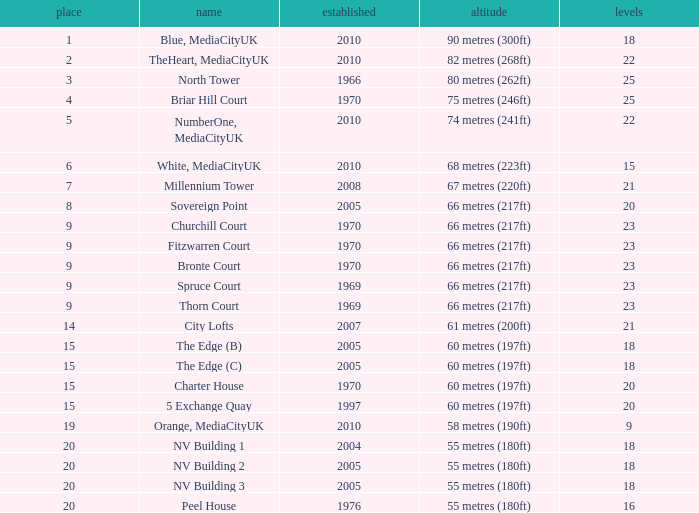What is the total number of Built, when Floors is less than 22, when Rank is less than 8, and when Name is White, Mediacityuk? 1.0. 